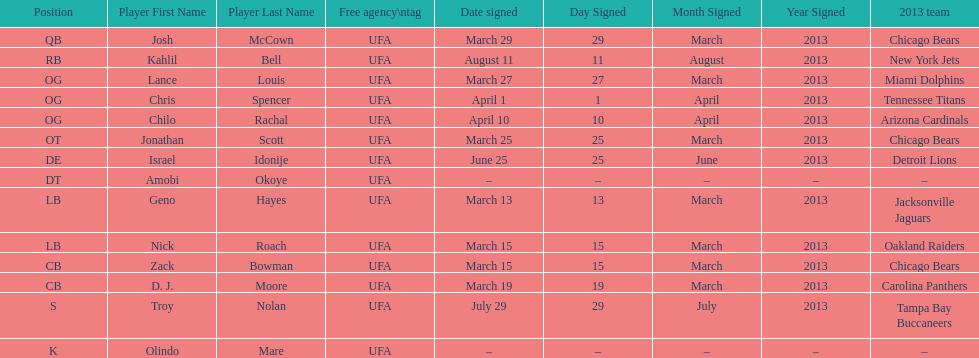What is the total of 2013 teams on the chart? 10. 